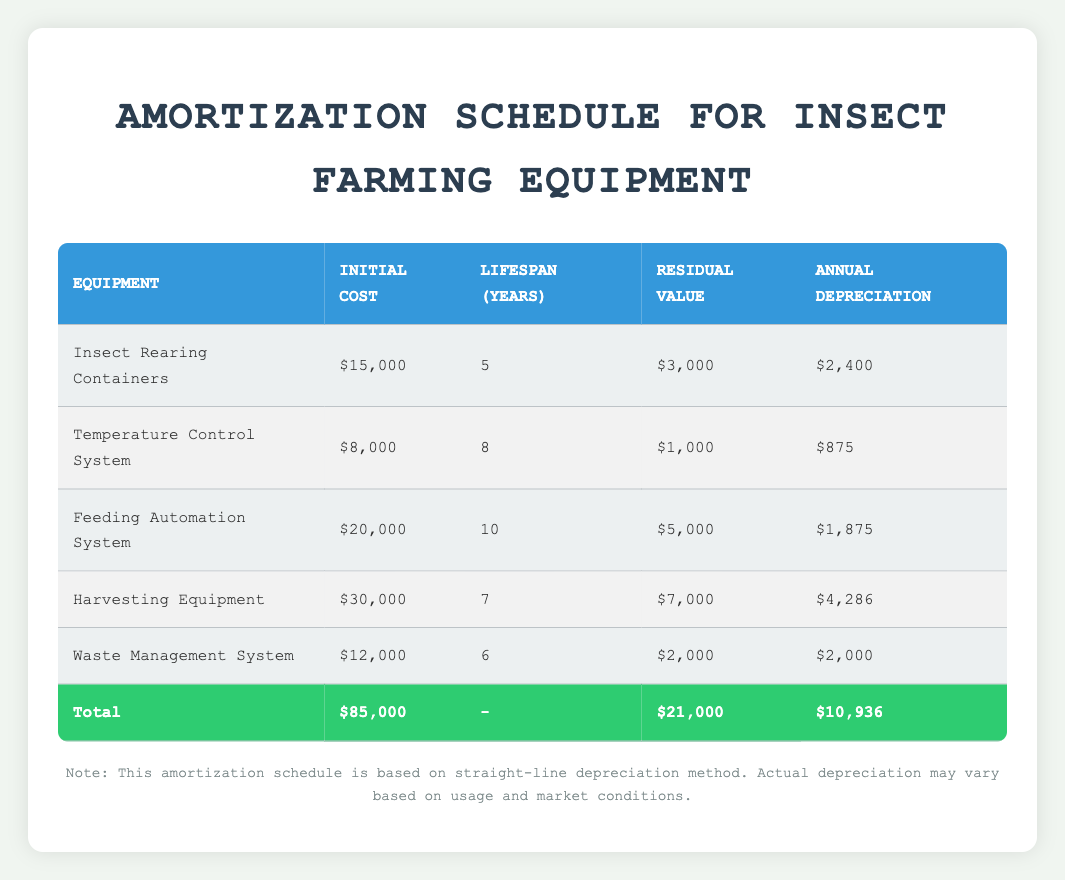What is the initial cost of the Harvesting Equipment? The table lists the Harvesting Equipment under the Equipment column, and the corresponding initial cost is provided in the second column. It states the initial cost is 30,000.
Answer: 30,000 What is the total annual depreciation for all the equipment combined? The last row in the table summarizes the total annual depreciation value, which is explicitly given as 10,936.
Answer: 10,936 How much is the residual value of the Temperature Control System? By locating the Temperature Control System in the table, we can see the residual value listed in the fourth column, which is 1,000.
Answer: 1,000 Which equipment has the highest annual depreciation? We compare the annual depreciation values listed for each equipment. The Harvesting Equipment has the highest value at 4,286.
Answer: Harvesting Equipment What is the average lifespan of all the equipment? The lifespans are 5, 8, 10, 7, and 6 years. Adding these values gives us 36 years. There are 5 pieces of equipment, so the average lifespan is 36/5 = 7.2 years.
Answer: 7.2 years Is the initial cost of the Waste Management System lower than the Temperature Control System? The initial cost of the Waste Management System is 12,000, which is greater than that of the Temperature Control System, listed at 8,000. Thus, the statement is false.
Answer: No What is the total residual value for all the equipment combined? The last row provides the total residual value for all equipment, showing a total of 21,000.
Answer: 21,000 If we sum the annual depreciation of the Insect Rearing Containers and the Feeding Automation System, what do we get? The Insect Rearing Containers have an annual depreciation of 2,400 and the Feeding Automation System has 1,875. Summing these gives us 2,400 + 1,875 = 4,275.
Answer: 4,275 Can we say that all equipment has a lifespan greater than 5 years? By looking at the lifespans in the table, the shortest lifespan is 5 years for the Insect Rearing Containers, so at least one equipment does meet the criteria. Therefore, it is true that not all equipment has lifespans greater than 5 years.
Answer: No 